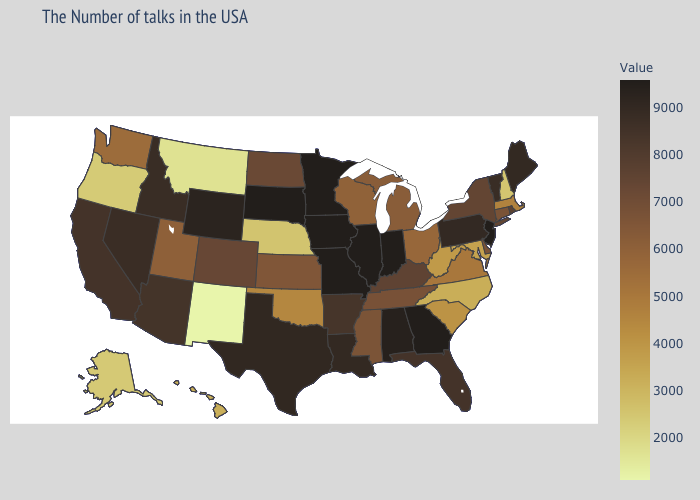Does Mississippi have a lower value than South Carolina?
Write a very short answer. No. Does Alabama have the lowest value in the South?
Be succinct. No. Which states have the lowest value in the USA?
Concise answer only. New Mexico. Does North Carolina have the lowest value in the South?
Quick response, please. Yes. Does Florida have the lowest value in the South?
Keep it brief. No. 